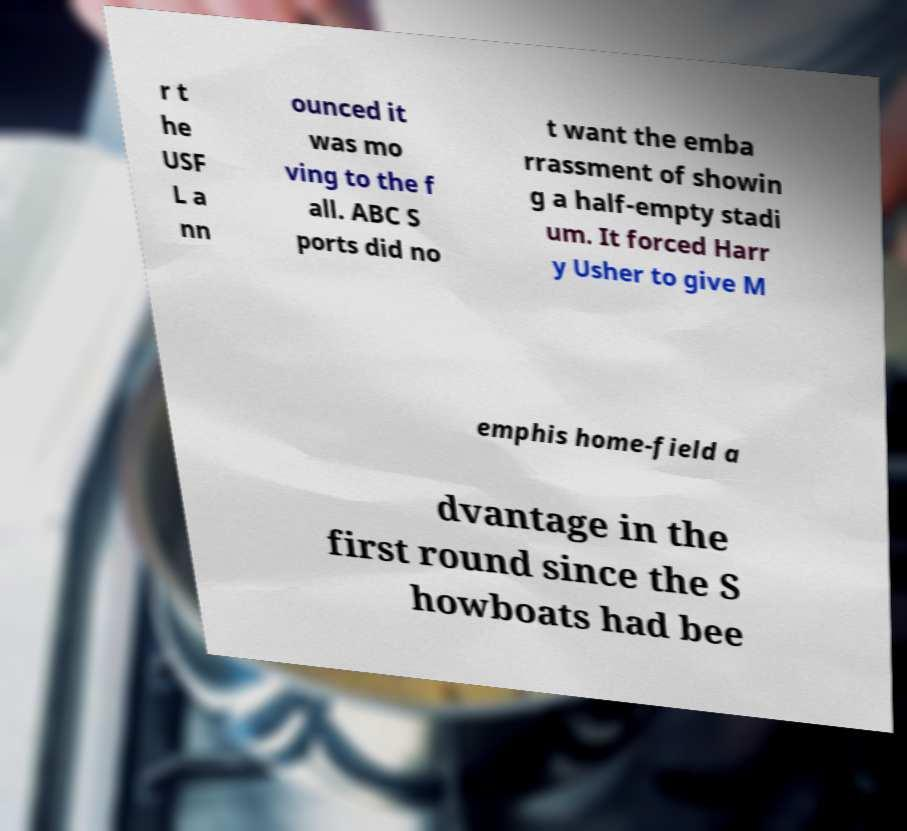Can you accurately transcribe the text from the provided image for me? r t he USF L a nn ounced it was mo ving to the f all. ABC S ports did no t want the emba rrassment of showin g a half-empty stadi um. It forced Harr y Usher to give M emphis home-field a dvantage in the first round since the S howboats had bee 